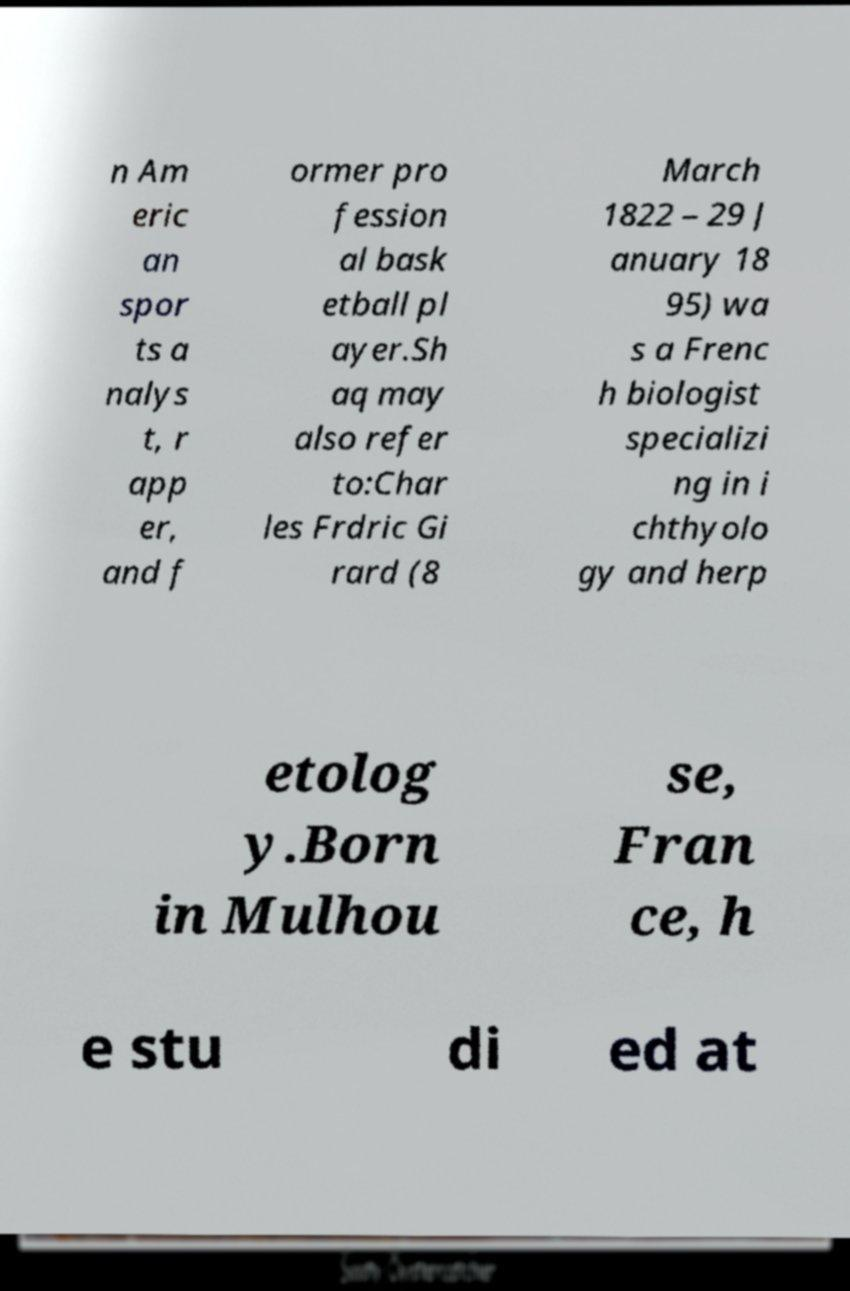What messages or text are displayed in this image? I need them in a readable, typed format. n Am eric an spor ts a nalys t, r app er, and f ormer pro fession al bask etball pl ayer.Sh aq may also refer to:Char les Frdric Gi rard (8 March 1822 – 29 J anuary 18 95) wa s a Frenc h biologist specializi ng in i chthyolo gy and herp etolog y.Born in Mulhou se, Fran ce, h e stu di ed at 